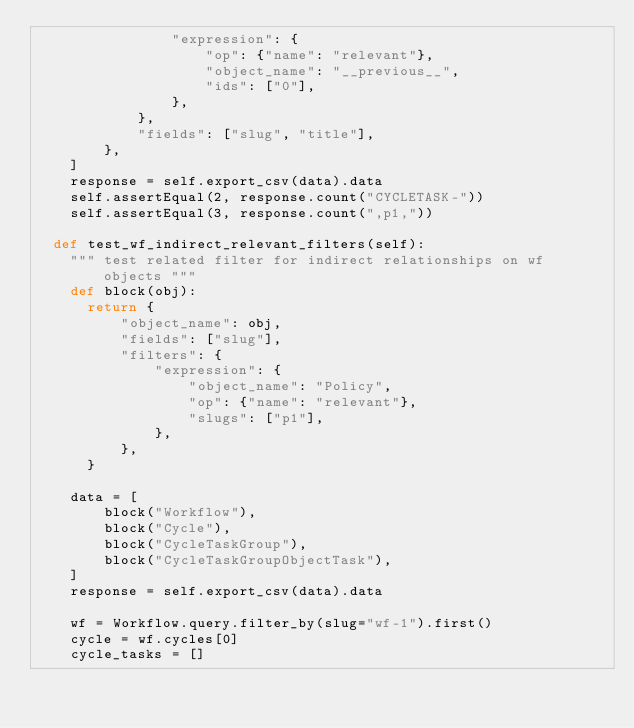<code> <loc_0><loc_0><loc_500><loc_500><_Python_>                "expression": {
                    "op": {"name": "relevant"},
                    "object_name": "__previous__",
                    "ids": ["0"],
                },
            },
            "fields": ["slug", "title"],
        },
    ]
    response = self.export_csv(data).data
    self.assertEqual(2, response.count("CYCLETASK-"))
    self.assertEqual(3, response.count(",p1,"))

  def test_wf_indirect_relevant_filters(self):
    """ test related filter for indirect relationships on wf objects """
    def block(obj):
      return {
          "object_name": obj,
          "fields": ["slug"],
          "filters": {
              "expression": {
                  "object_name": "Policy",
                  "op": {"name": "relevant"},
                  "slugs": ["p1"],
              },
          },
      }

    data = [
        block("Workflow"),
        block("Cycle"),
        block("CycleTaskGroup"),
        block("CycleTaskGroupObjectTask"),
    ]
    response = self.export_csv(data).data

    wf = Workflow.query.filter_by(slug="wf-1").first()
    cycle = wf.cycles[0]
    cycle_tasks = []</code> 